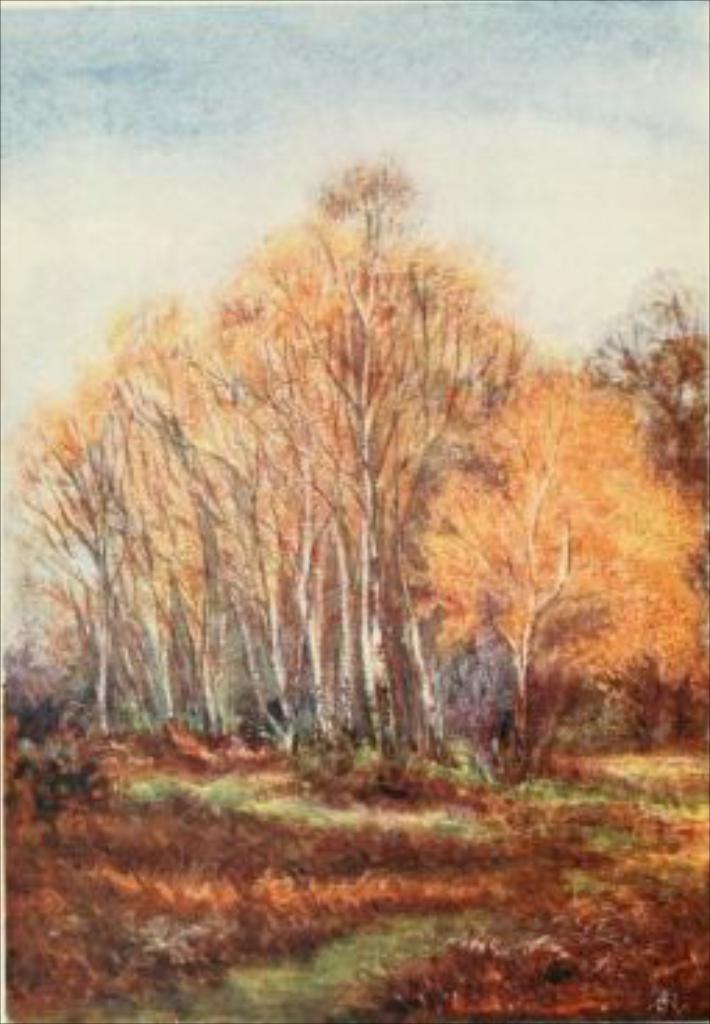In one or two sentences, can you explain what this image depicts? It is a painting of a forest,there is some grass and lot of tall trees are drawn. 